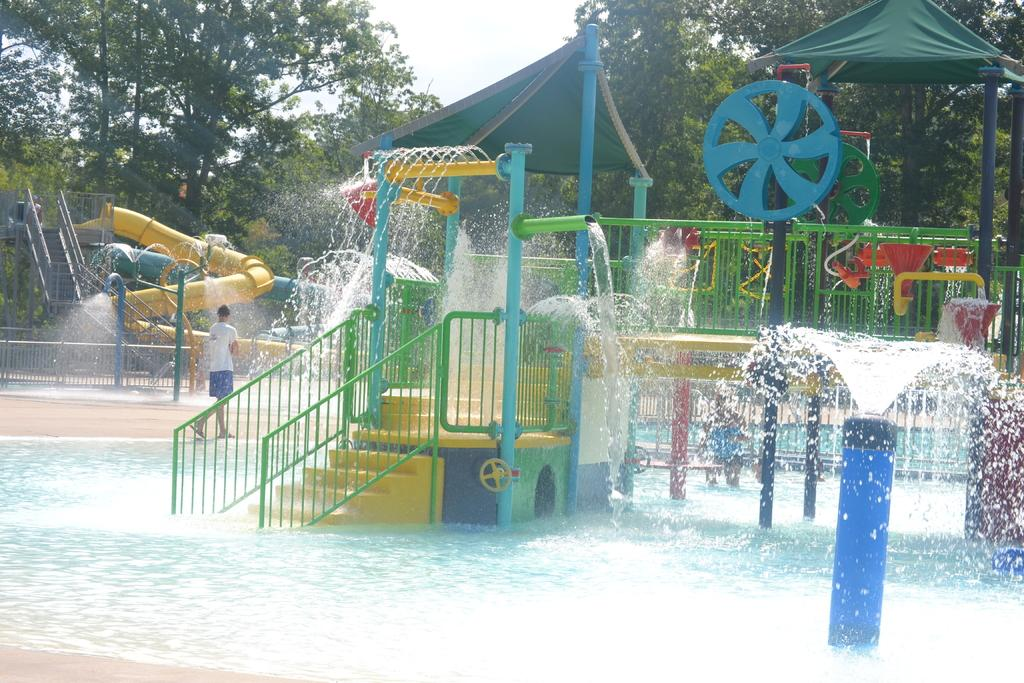What type of recreational facility is shown in the image? There is a water park in the image. Can you describe the person in the image? There is a person in the image, but their specific appearance or actions are not mentioned in the provided facts. What architectural feature is present in the image? There are stairs in the image. What type of temporary shelter is present in the image? There are tents in the image. What type of vegetation is present in the image? There are trees in the image. What is visible in the background of the image? The sky is visible in the background of the image. What type of coal is being used to fuel the water park in the image? There is no mention of coal or any fuel source in the image; the water park is likely powered by electricity or other non-fossil fuel sources. 